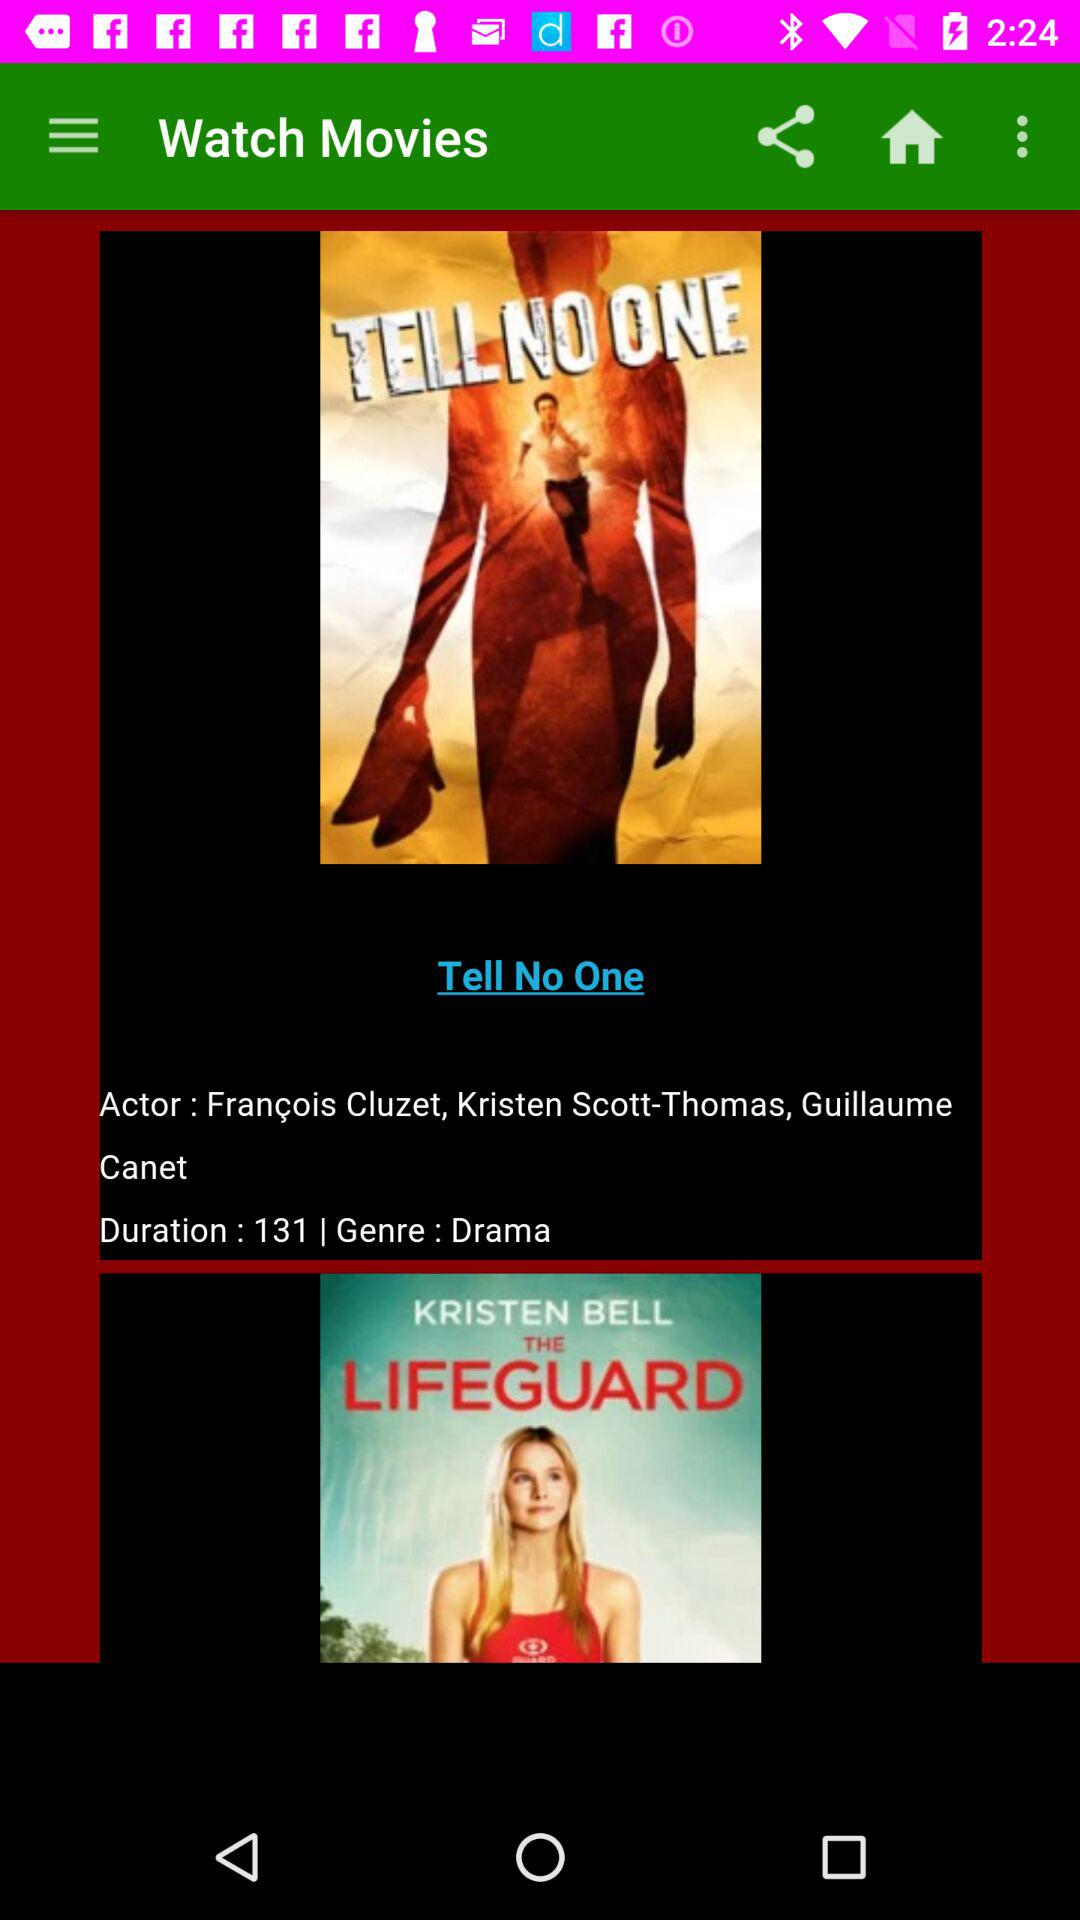What is the title of the movie whose duration is 131? The title of the movie is Tell No One. 